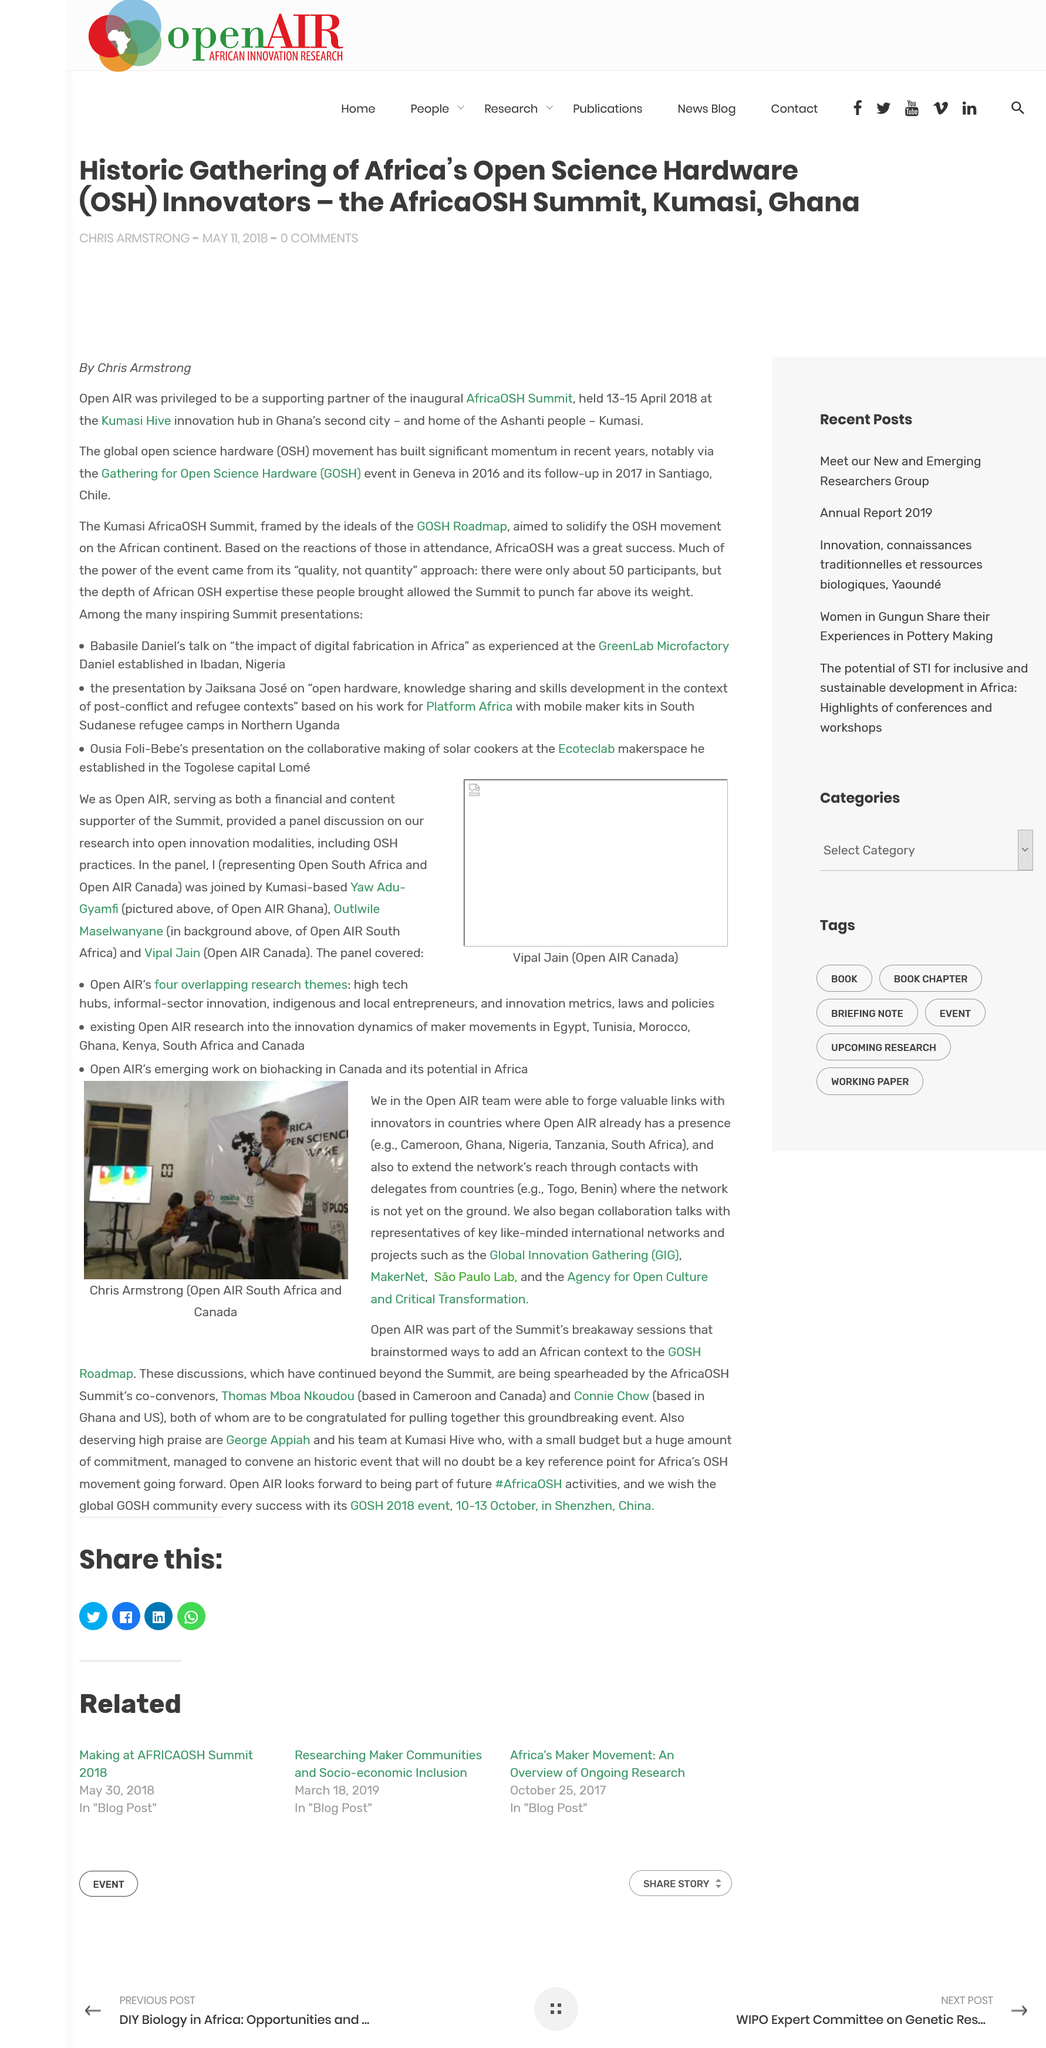Point out several critical features in this image. Chris Armstrong works for Open AIR South Africa and Canada, an organization that focuses on promoting research and innovation in the field of digital economy and society. Open AIR has a presence in Ghana, and this is evidenced by the fact that they have a presence in Ghana. The name of the man in the image is Chris Armstrong. 